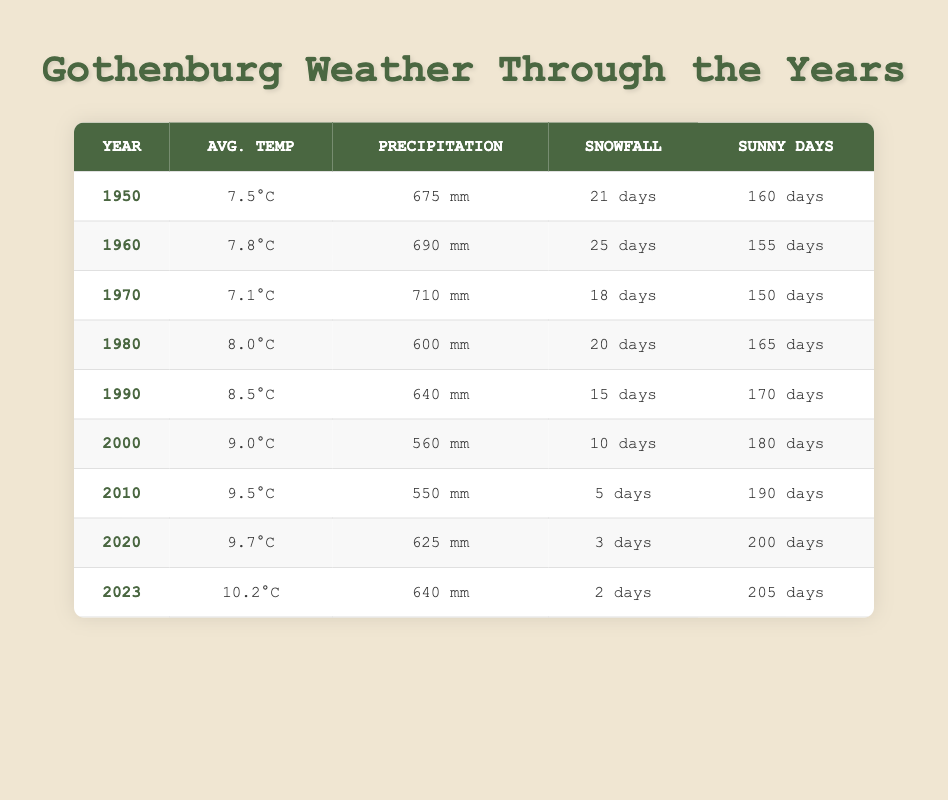What was the average temperature in 1980? From the table, the average temperature for the year 1980 is shown directly in the "Avg. Temp" column. Looking at the row for 1980, I see that it is 8.0 degrees Celsius.
Answer: 8.0 How many sunny days were recorded in Gothenburg in 2023? The number of sunny days for the year 2023 can be found in the "Sunny Days" column. Checking the table, the entry for 2023 indicates there were 205 sunny days.
Answer: 205 What is the total precipitation recorded for the years 1990 and 2000 combined? To find the total precipitation for those years, I refer to the "Precipitation" column. For 1990, the precipitation is 640 mm, and for 2000, it is 560 mm. Adding these two amounts gives 640 + 560 = 1200 mm.
Answer: 1200 mm In which year did Gothenburg have the least snowfall? From the "Snowfall" column, I can compare the snowfall days for each year. The year 2023 has 2 snowfall days, which is less than any other year in the table. Thus, 2023 is the year with the least snowfall.
Answer: 2023 Was the average temperature in 2010 higher than that in 2000? I first look up the average temperature for each year in the "Avg. Temp" column. For 2000, it is 9.0 degrees Celsius, and for 2010, it is 9.5 degrees Celsius. Since 9.5 is greater than 9.0, I conclude that yes, it was higher.
Answer: Yes What was the average temperature increase from 1970 to 2023? I find the average temperature for both years in the "Avg. Temp" column. In 1970, it was 7.1 degrees Celsius and in 2023, it was 10.2 degrees Celsius. The increase can be calculated as 10.2 - 7.1 = 3.1 degrees Celsius.
Answer: 3.1 Did the total precipitation in 1960 exceed that of 1980? I check the "Precipitation" column for both years. The total precipitation for 1960 is 690 mm and for 1980, it is 600 mm. Since 690 mm is greater than 600 mm, I confirm that it did indeed exceed that.
Answer: Yes How many more sunny days were there in 2023 compared to 2010? From the "Sunny Days" column, I see that in 2023, there were 205 sunny days and in 2010, there were 190 sunny days. To find the difference, I subtract 190 from 205, giving me 205 - 190 = 15 more sunny days in 2023.
Answer: 15 